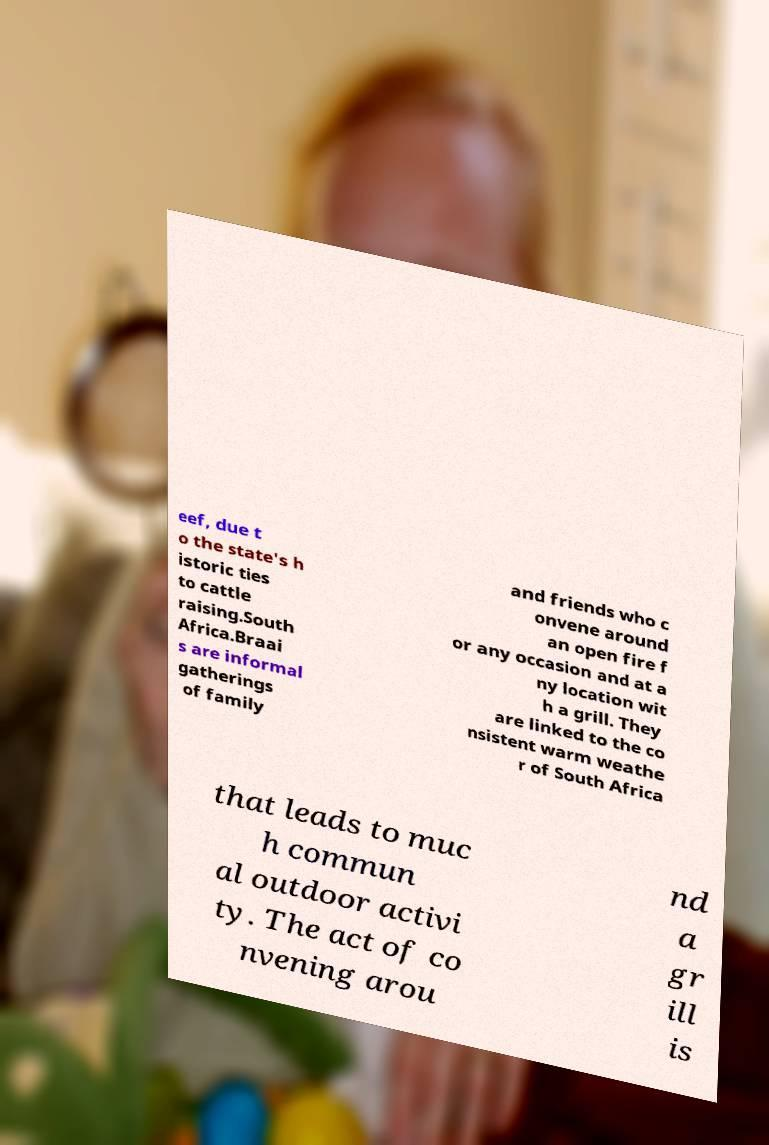There's text embedded in this image that I need extracted. Can you transcribe it verbatim? eef, due t o the state's h istoric ties to cattle raising.South Africa.Braai s are informal gatherings of family and friends who c onvene around an open fire f or any occasion and at a ny location wit h a grill. They are linked to the co nsistent warm weathe r of South Africa that leads to muc h commun al outdoor activi ty. The act of co nvening arou nd a gr ill is 